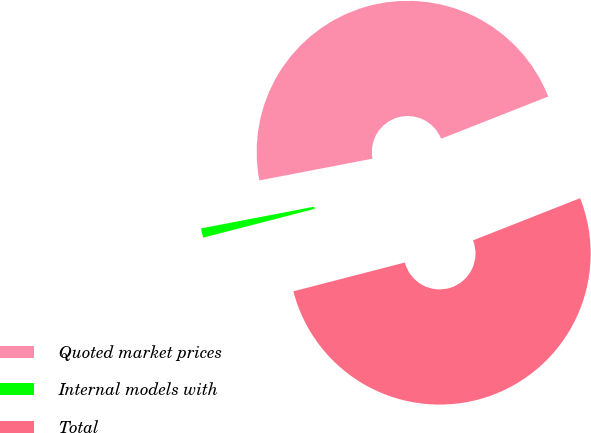<chart> <loc_0><loc_0><loc_500><loc_500><pie_chart><fcel>Quoted market prices<fcel>Internal models with<fcel>Total<nl><fcel>47.05%<fcel>1.0%<fcel>51.95%<nl></chart> 